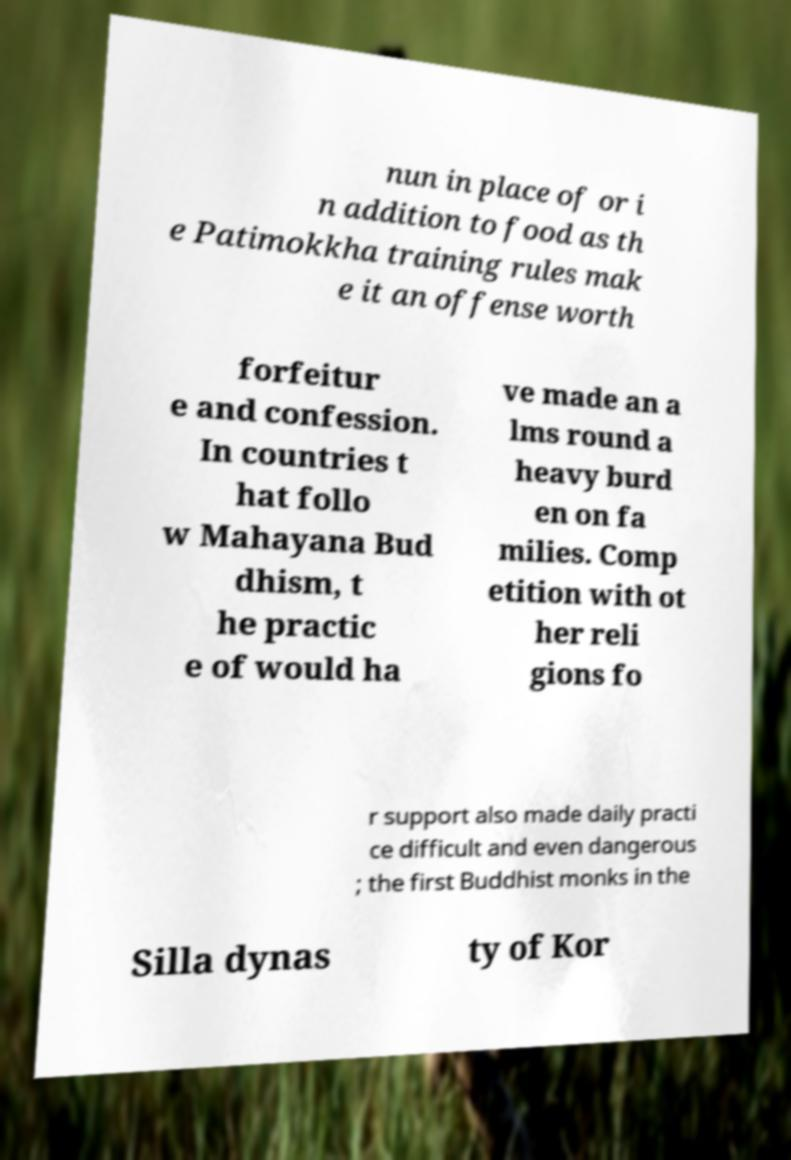Please identify and transcribe the text found in this image. nun in place of or i n addition to food as th e Patimokkha training rules mak e it an offense worth forfeitur e and confession. In countries t hat follo w Mahayana Bud dhism, t he practic e of would ha ve made an a lms round a heavy burd en on fa milies. Comp etition with ot her reli gions fo r support also made daily practi ce difficult and even dangerous ; the first Buddhist monks in the Silla dynas ty of Kor 